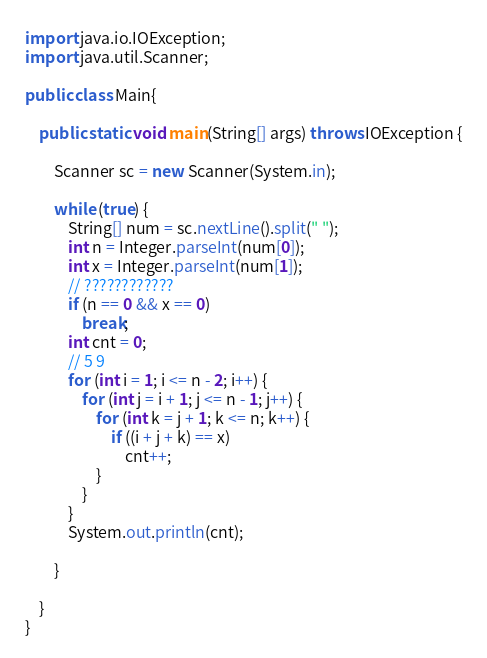Convert code to text. <code><loc_0><loc_0><loc_500><loc_500><_Java_>

import java.io.IOException;
import java.util.Scanner;

public class Main{

	public static void main(String[] args) throws IOException {

		Scanner sc = new Scanner(System.in);

		while (true) {
			String[] num = sc.nextLine().split(" ");
			int n = Integer.parseInt(num[0]);
			int x = Integer.parseInt(num[1]);
			// ????????????
			if (n == 0 && x == 0)
				break;
			int cnt = 0;
			// 5 9
			for (int i = 1; i <= n - 2; i++) {
                for (int j = i + 1; j <= n - 1; j++) {
                    for (int k = j + 1; k <= n; k++) {
                        if ((i + j + k) == x)
                            cnt++;
                    }
				}
			}
			System.out.println(cnt);

		}

	}
}</code> 